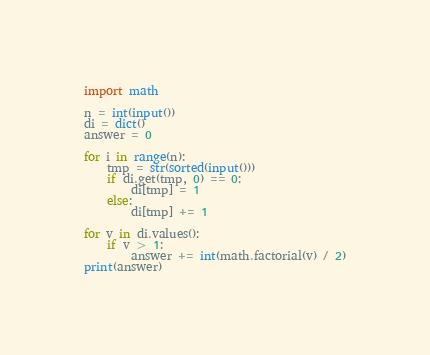<code> <loc_0><loc_0><loc_500><loc_500><_Python_>import math

n = int(input())
di = dict()
answer = 0

for i in range(n):
    tmp = str(sorted(input()))
    if di.get(tmp, 0) == 0:
        di[tmp] = 1
    else:
        di[tmp] += 1

for v in di.values():
    if v > 1:
        answer += int(math.factorial(v) / 2)
print(answer)


</code> 